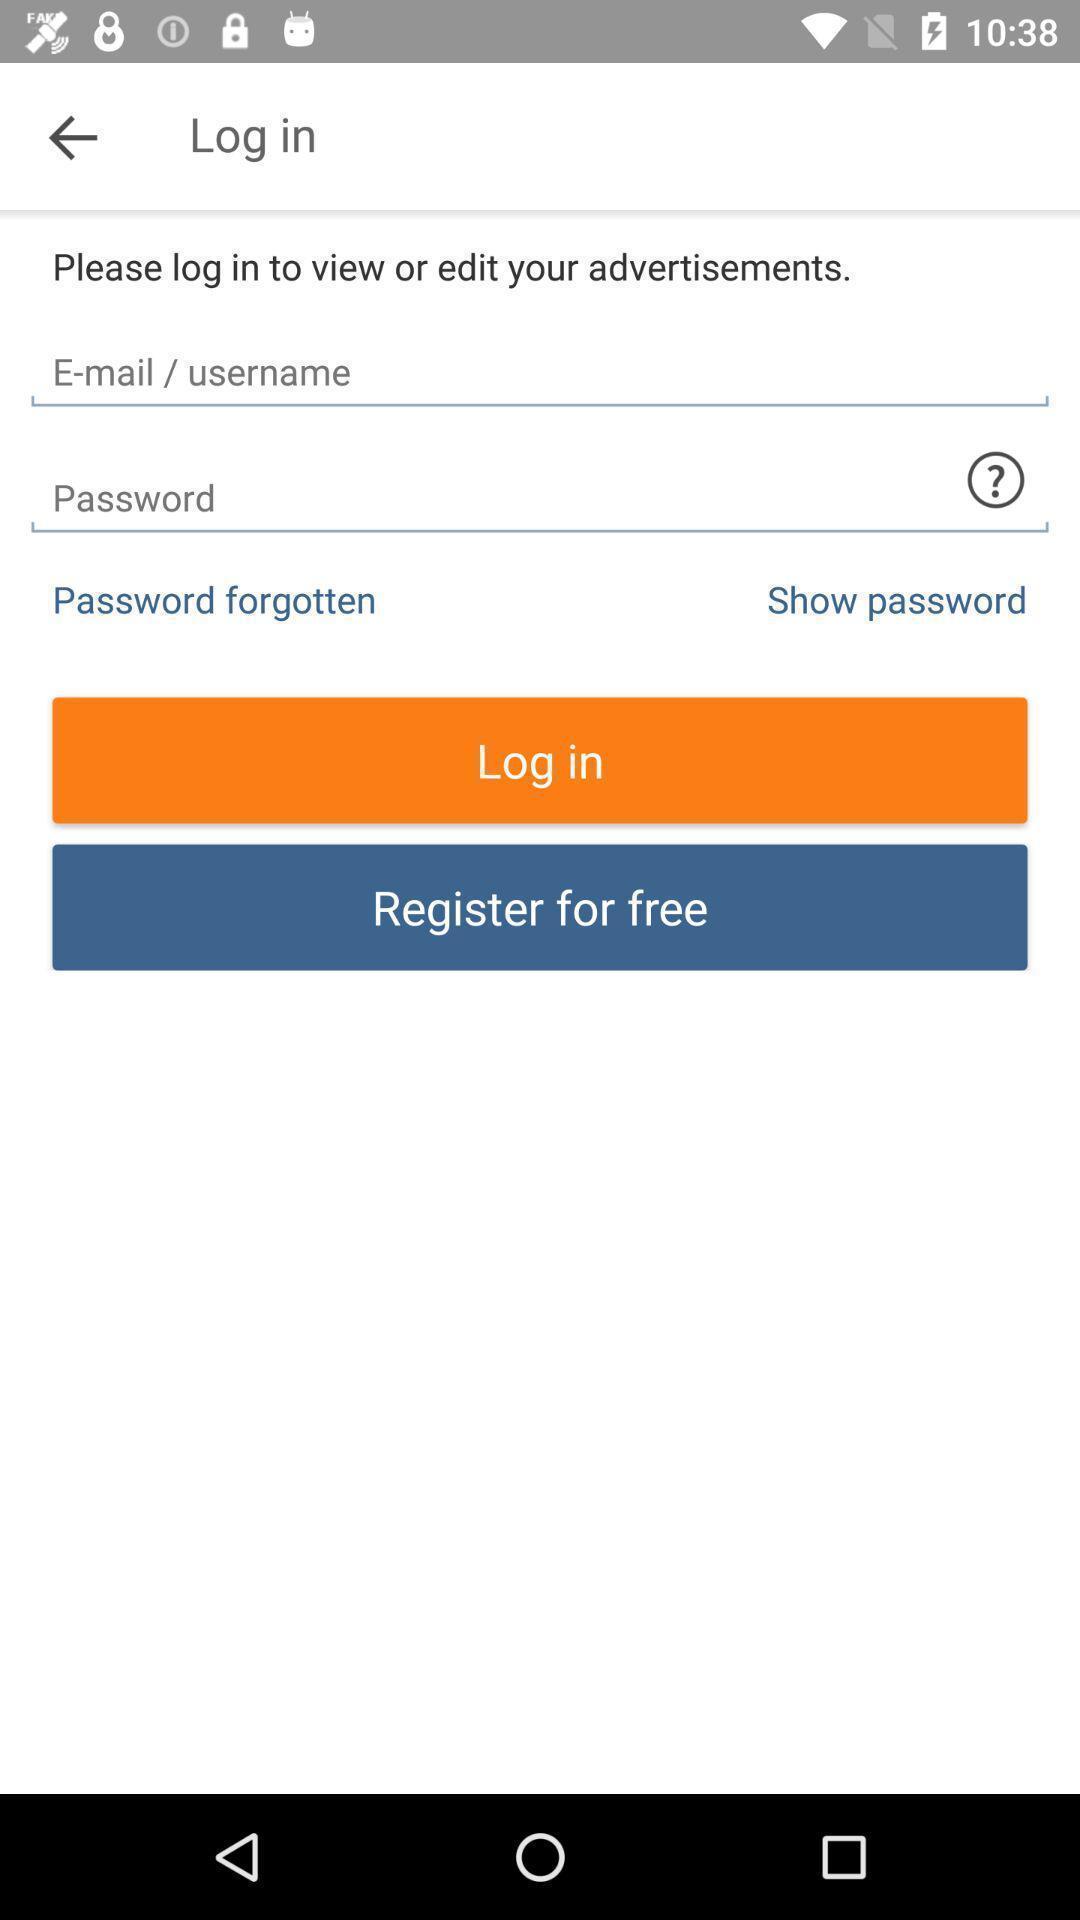Tell me about the visual elements in this screen capture. Page showing log in option. 